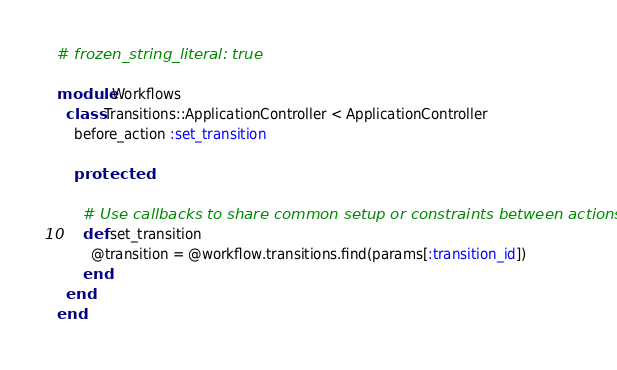Convert code to text. <code><loc_0><loc_0><loc_500><loc_500><_Ruby_># frozen_string_literal: true

module Workflows
  class Transitions::ApplicationController < ApplicationController
    before_action :set_transition

    protected

      # Use callbacks to share common setup or constraints between actions.
      def set_transition
        @transition = @workflow.transitions.find(params[:transition_id])
      end
  end
end
</code> 